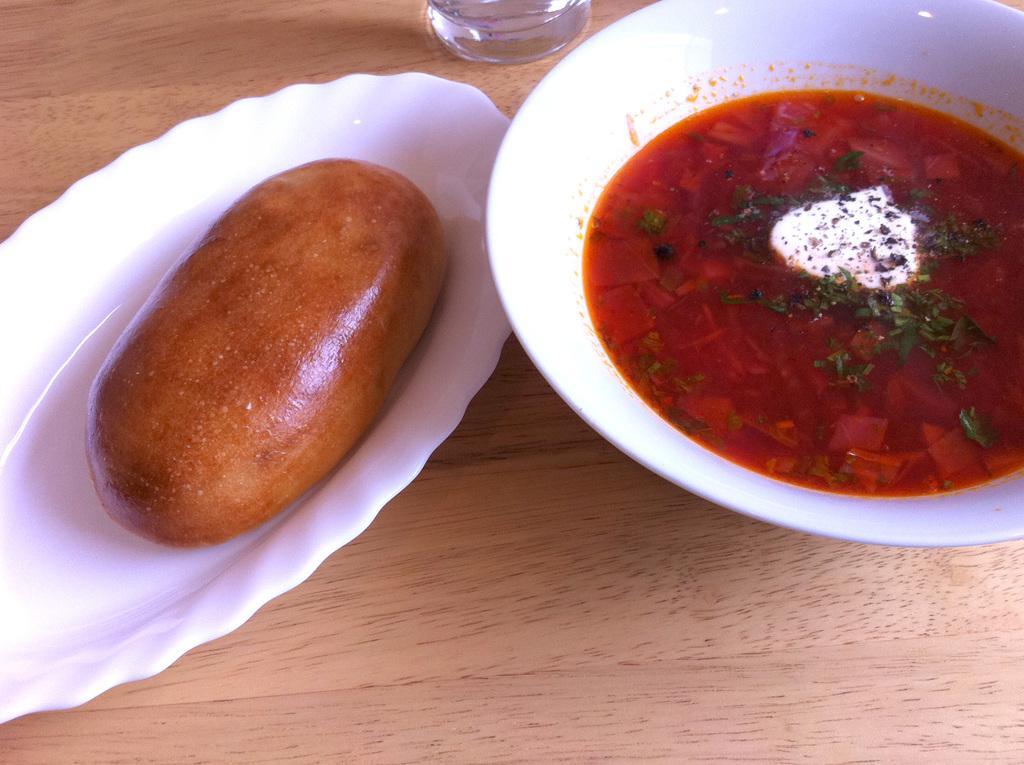In one or two sentences, can you explain what this image depicts? In the center of the image we can see some food in bowl and plate placed on the table. 